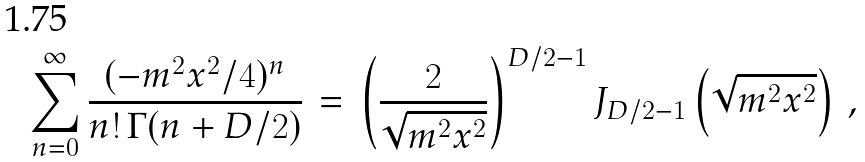Convert formula to latex. <formula><loc_0><loc_0><loc_500><loc_500>\sum _ { n = 0 } ^ { \infty } \frac { ( - m ^ { 2 } x ^ { 2 } / 4 ) ^ { n } } { n ! \, \Gamma ( n + D / 2 ) } \, = \, \left ( \frac { 2 } { \sqrt { m ^ { 2 } x ^ { 2 } } } \right ) ^ { D / 2 - 1 } J _ { D / 2 - 1 } \left ( \sqrt { m ^ { 2 } x ^ { 2 } } \right ) \, ,</formula> 